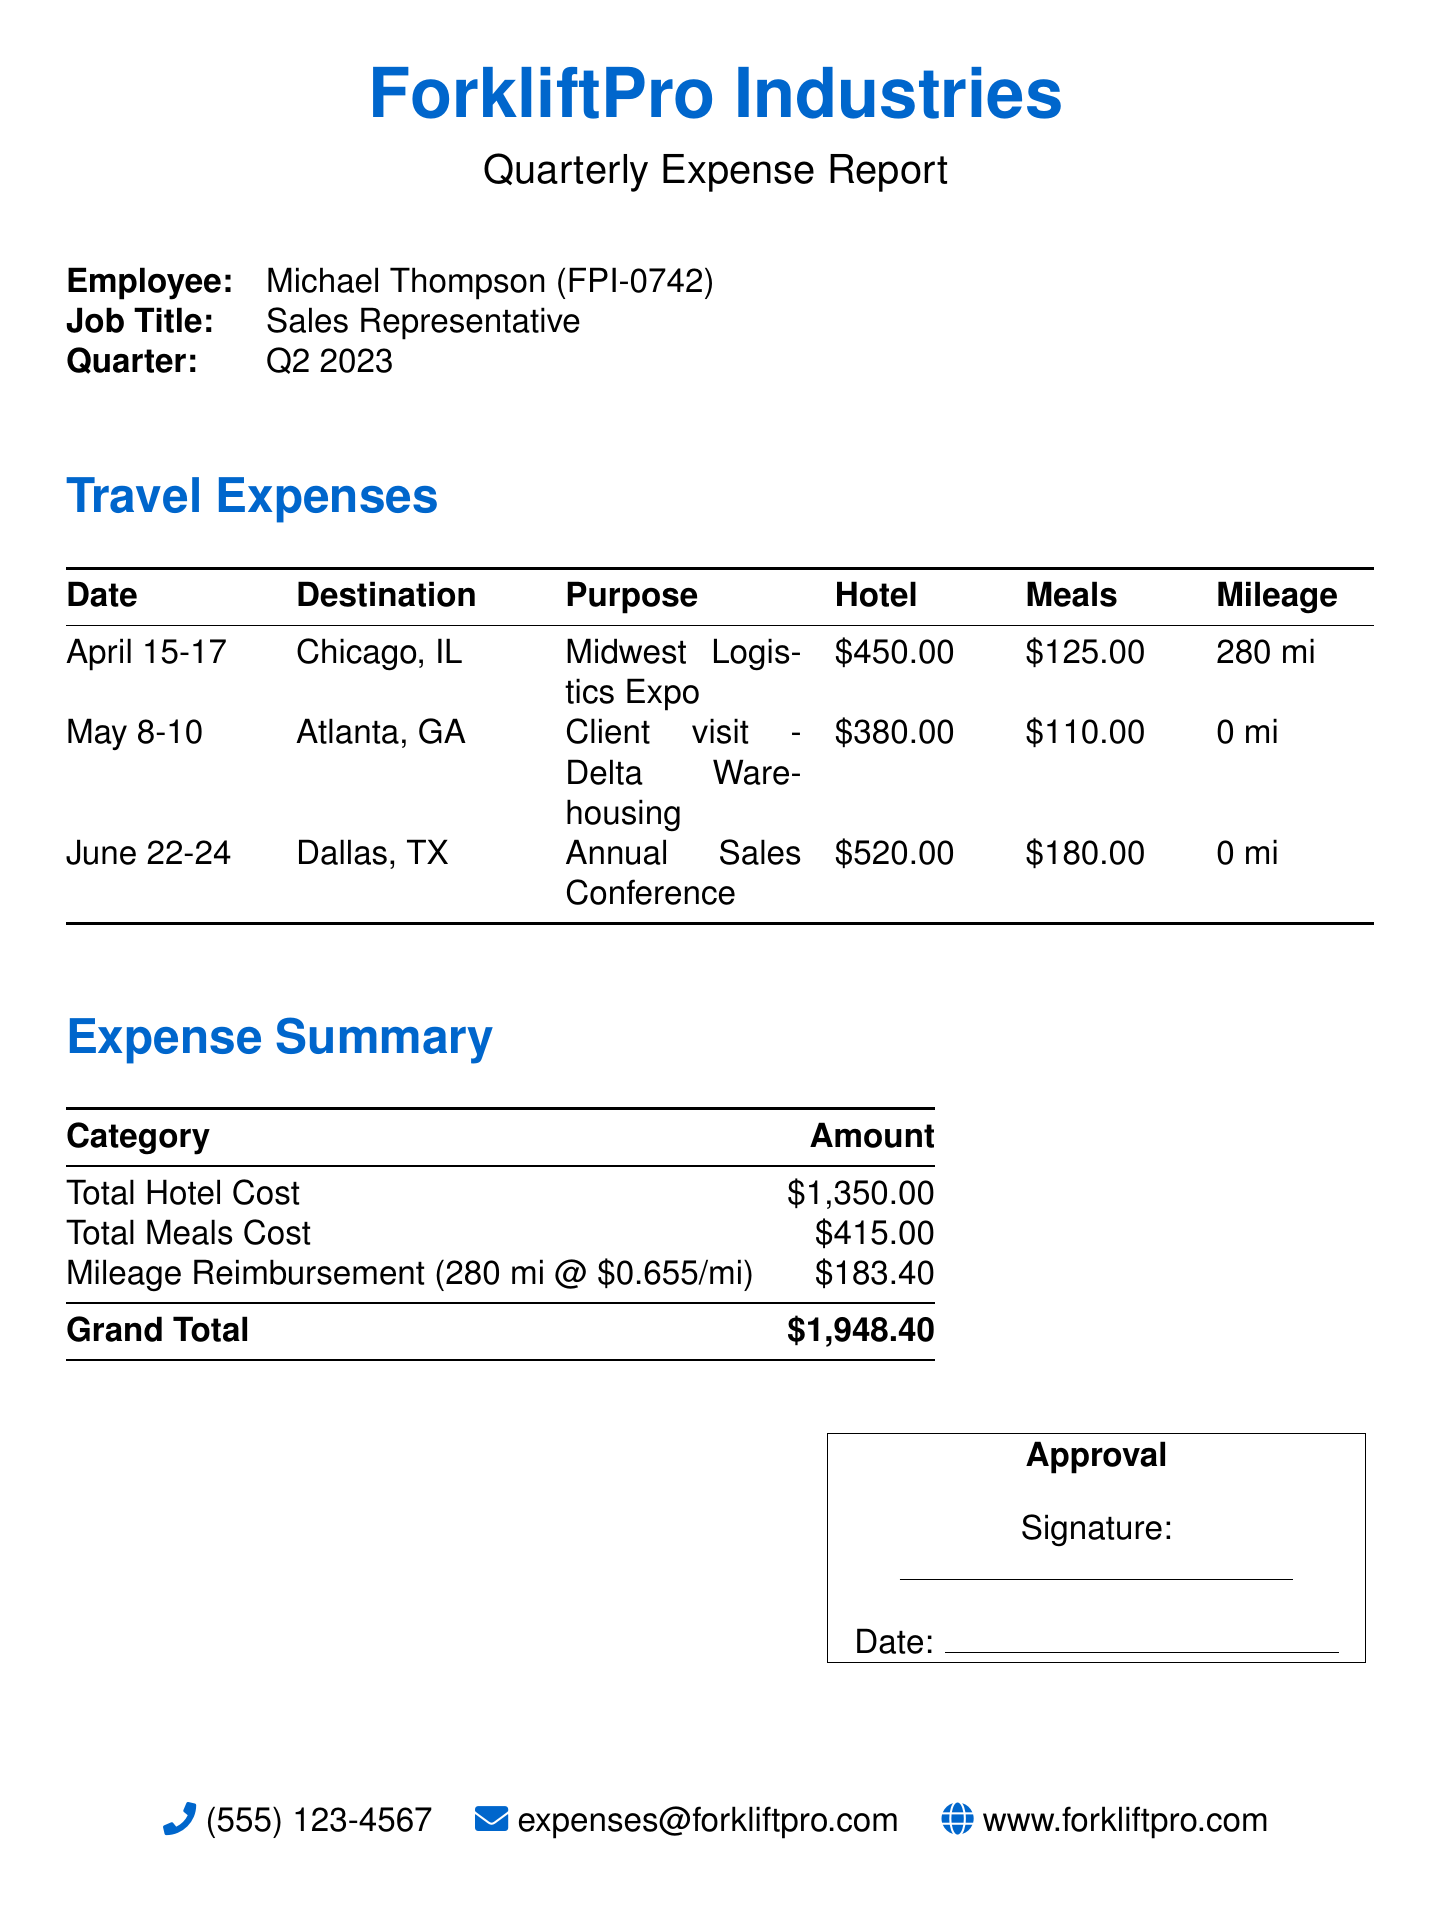What is the employee's name? The document states the employee's name as Michael Thompson.
Answer: Michael Thompson What is the total hotel cost? The total hotel cost is provided in the expense summary as $1,350.00.
Answer: $1,350.00 What was the purpose of the trip to Atlanta, GA? The purpose of the trip to Atlanta, GA is listed as Client visit - Delta Warehousing.
Answer: Client visit - Delta Warehousing How much was spent on meals during the trip? The total meals cost is stated in the expense summary as $415.00.
Answer: $415.00 What is the date range for the Chicago trip? The date range for the Chicago trip is mentioned as April 15-17.
Answer: April 15-17 How many miles were reimbursed for travel? The mileage reimbursement listed in the document is for 280 miles.
Answer: 280 mi What is the grand total for the expenses? The grand total for the expenses is provided as $1,948.40.
Answer: $1,948.40 What was the amount reimbursed for mileage? The mileage reimbursement amount is stated as $183.40.
Answer: $183.40 What is the job title of the employee? The document lists the job title of the employee as Sales Representative.
Answer: Sales Representative 